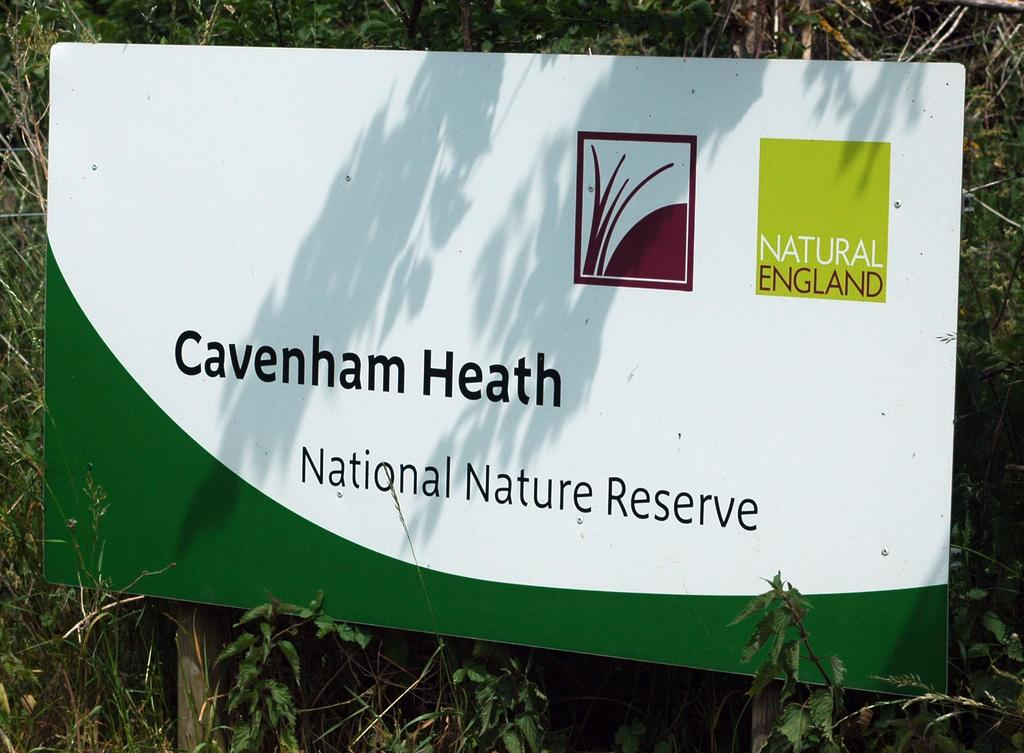What is the main subject of the image? The main subject of the image is a nature reserve board. What type of natural environment can be seen in the image? Trees and bushes are visible in the image. What type of books can be seen in the library in the image? There is no library present in the image; it features a nature reserve board surrounded by trees and bushes. 